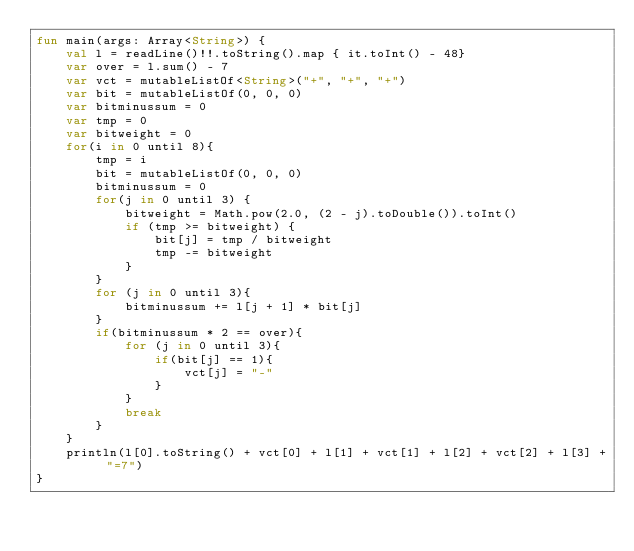<code> <loc_0><loc_0><loc_500><loc_500><_Kotlin_>fun main(args: Array<String>) {
    val l = readLine()!!.toString().map { it.toInt() - 48}
    var over = l.sum() - 7
    var vct = mutableListOf<String>("+", "+", "+")
    var bit = mutableListOf(0, 0, 0)
    var bitminussum = 0
    var tmp = 0
    var bitweight = 0
    for(i in 0 until 8){
        tmp = i
        bit = mutableListOf(0, 0, 0)
        bitminussum = 0
        for(j in 0 until 3) {
            bitweight = Math.pow(2.0, (2 - j).toDouble()).toInt()
            if (tmp >= bitweight) {
                bit[j] = tmp / bitweight
                tmp -= bitweight
            }
        }
        for (j in 0 until 3){
            bitminussum += l[j + 1] * bit[j]
        }
        if(bitminussum * 2 == over){
            for (j in 0 until 3){
                if(bit[j] == 1){
                    vct[j] = "-"
                }
            }
            break
        }
    }
    println(l[0].toString() + vct[0] + l[1] + vct[1] + l[2] + vct[2] + l[3] + "=7")
}</code> 